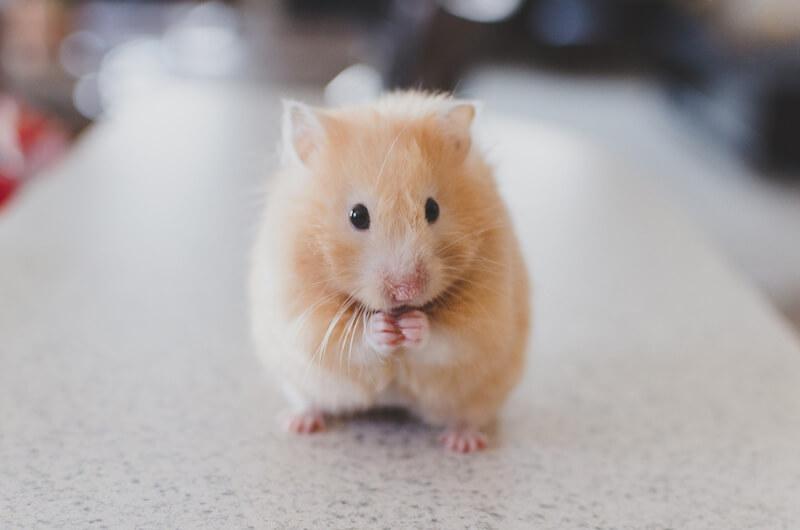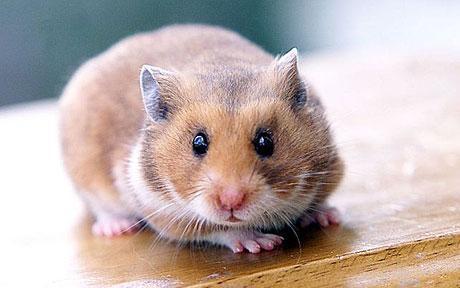The first image is the image on the left, the second image is the image on the right. Evaluate the accuracy of this statement regarding the images: "One of the images has a plain white background.". Is it true? Answer yes or no. No. 